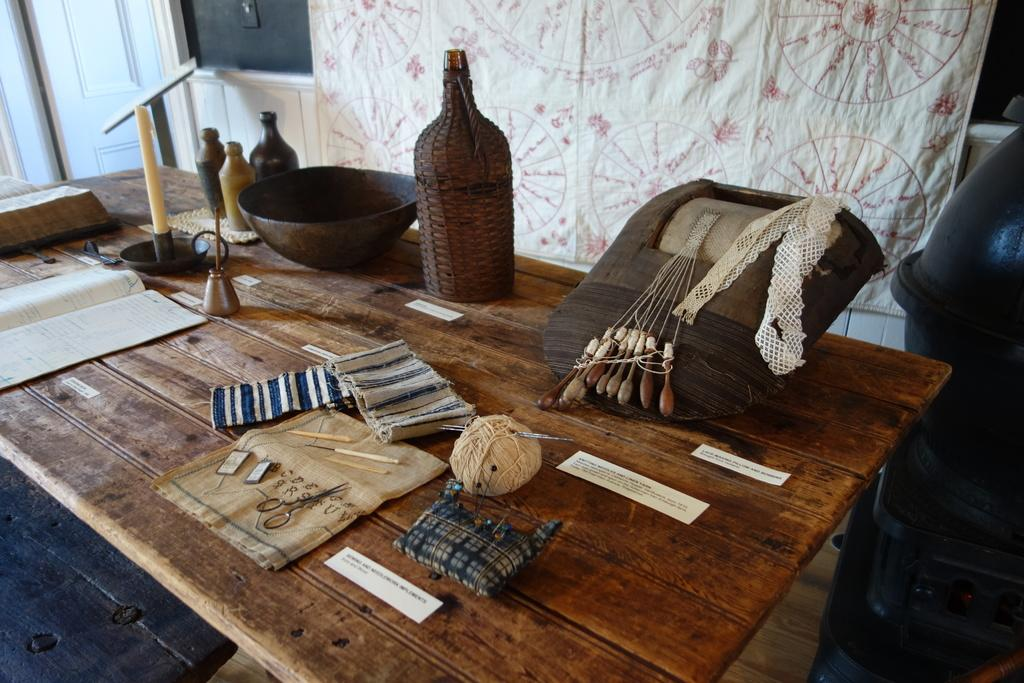What objects can be seen on the table in the image? There is a book, a candle stand, a candle, a bottle, a bowl, a bag, a scissor, a cloth, thread, and a small piece of paper on the table in the image. Can you describe the candle stand and the candle? The candle stand is on the table, and there is a candle placed on it. How many bottles are visible on the table? There are multiple bottles on the table in the image. What is in the background of the image? There is a door and a cloth in the background of the image. How many cats are sitting on the table in the image? There are no cats present on the table in the image. What type of hen can be seen in the image? There is no hen present in the image. 